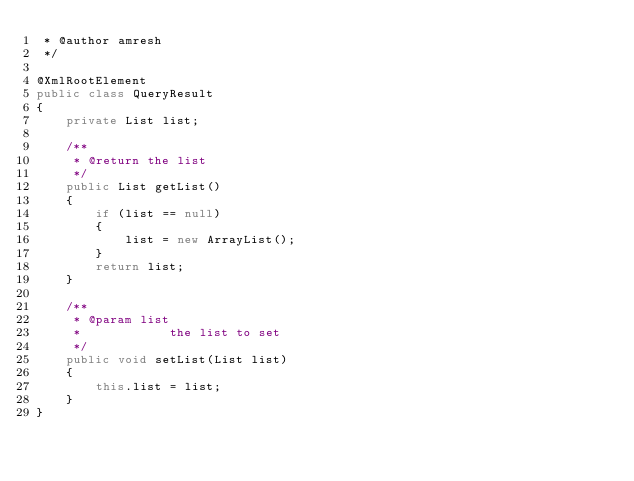<code> <loc_0><loc_0><loc_500><loc_500><_Java_> * @author amresh
 */

@XmlRootElement
public class QueryResult
{
    private List list;

    /**
     * @return the list
     */
    public List getList()
    {
        if (list == null)
        {
            list = new ArrayList();
        }
        return list;
    }

    /**
     * @param list
     *            the list to set
     */
    public void setList(List list)
    {
        this.list = list;
    }
}
</code> 